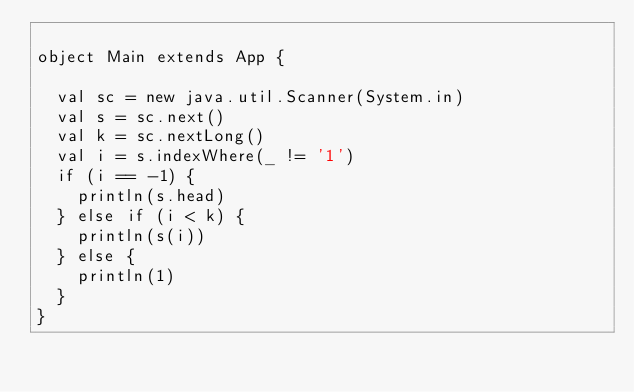<code> <loc_0><loc_0><loc_500><loc_500><_Scala_>
object Main extends App {
  
  val sc = new java.util.Scanner(System.in)
  val s = sc.next()
  val k = sc.nextLong()
  val i = s.indexWhere(_ != '1')
  if (i == -1) {
    println(s.head)
  } else if (i < k) {
    println(s(i))
  } else {
    println(1)
  }
}
</code> 